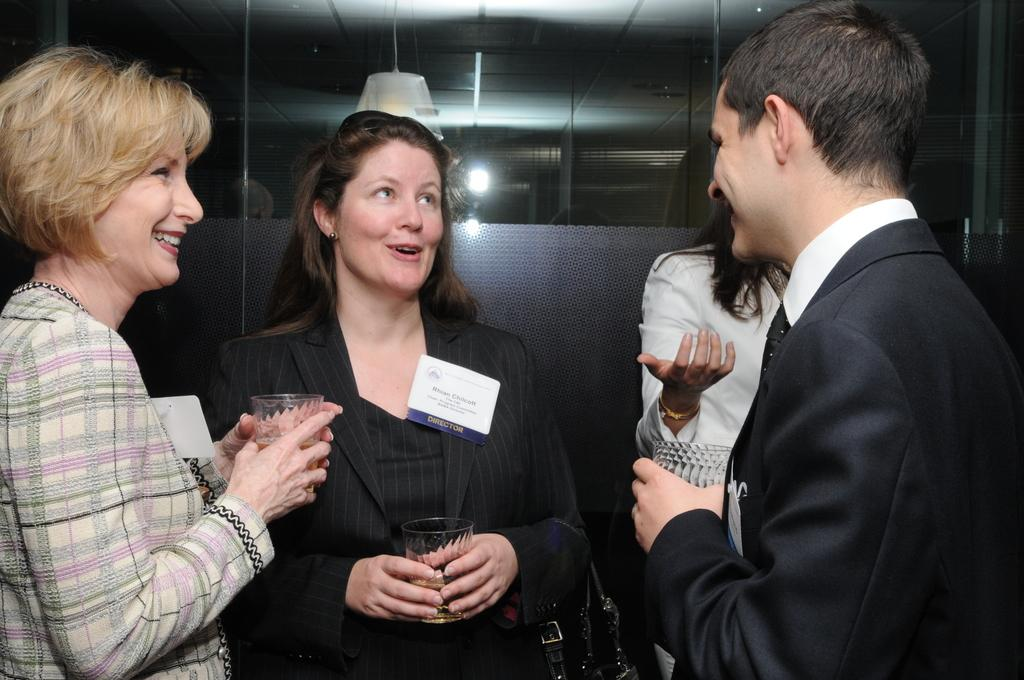What is the person in the image holding? The person is holding a tennis racket. Is there anything else related to tennis visible in the image? Yes, there is a tennis ball on the ground. What type of cable is being used to play the game in the image? There is no cable visible in the image, and it does not depict a game. 